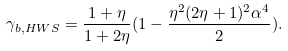<formula> <loc_0><loc_0><loc_500><loc_500>\gamma _ { b , H W S } = \frac { 1 + \eta } { 1 + 2 \eta } ( 1 - \frac { \eta ^ { 2 } ( 2 \eta + 1 ) ^ { 2 } \alpha ^ { 4 } } { 2 } ) .</formula> 